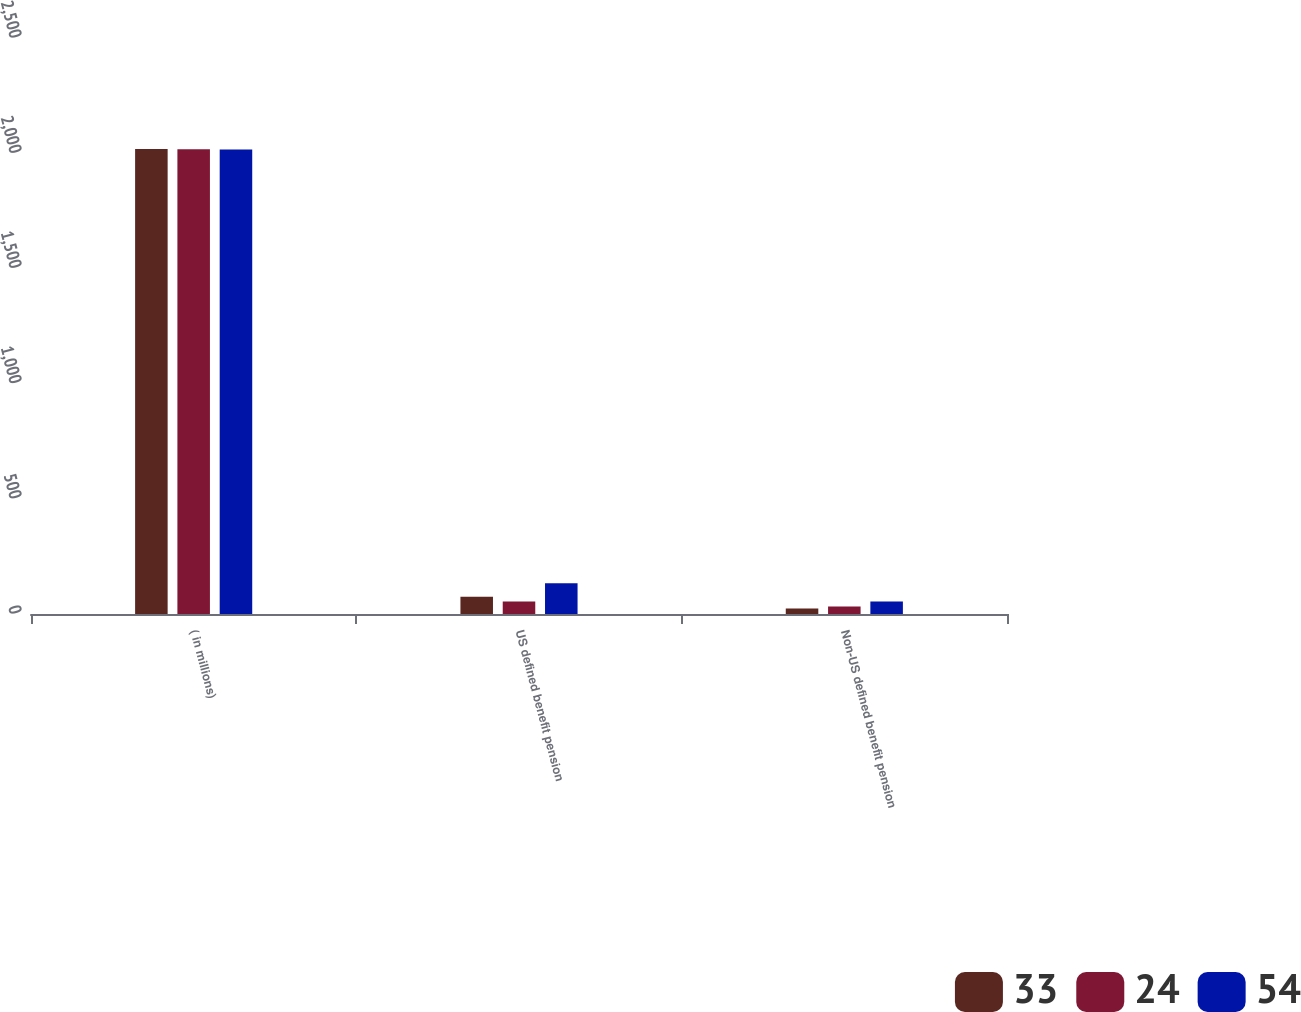Convert chart. <chart><loc_0><loc_0><loc_500><loc_500><stacked_bar_chart><ecel><fcel>( in millions)<fcel>US defined benefit pension<fcel>Non-US defined benefit pension<nl><fcel>33<fcel>2018<fcel>75<fcel>24<nl><fcel>24<fcel>2017<fcel>54<fcel>33<nl><fcel>54<fcel>2016<fcel>134<fcel>54<nl></chart> 